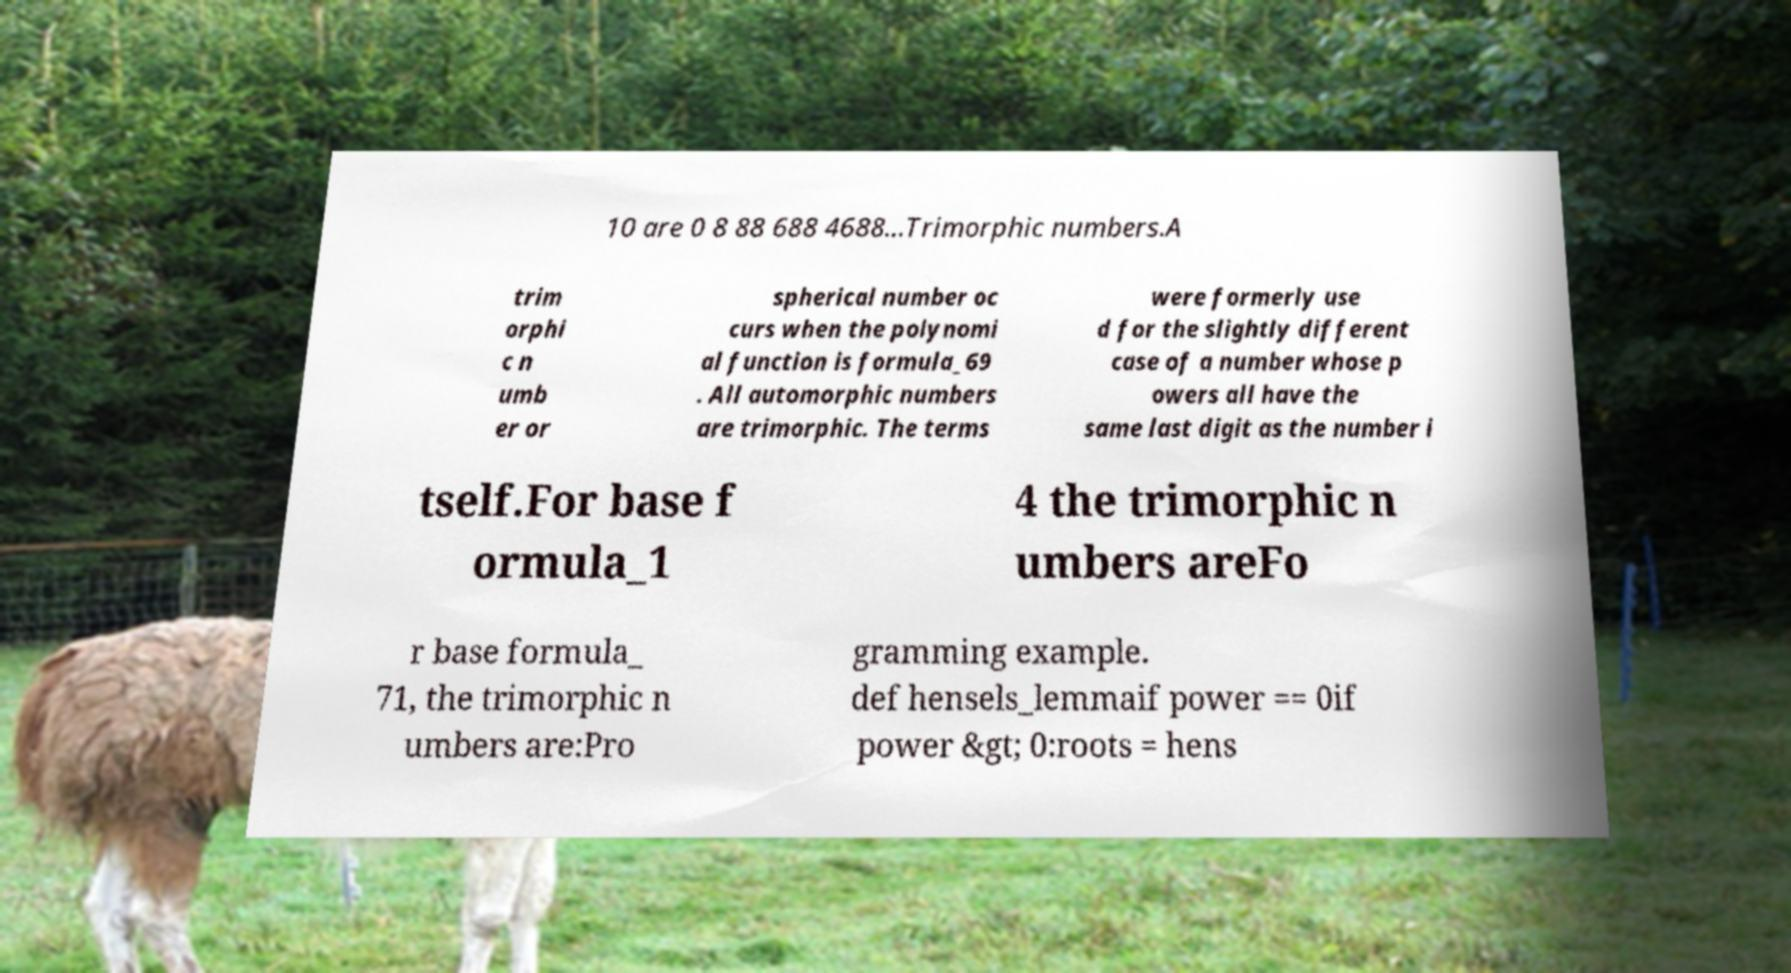What messages or text are displayed in this image? I need them in a readable, typed format. 10 are 0 8 88 688 4688...Trimorphic numbers.A trim orphi c n umb er or spherical number oc curs when the polynomi al function is formula_69 . All automorphic numbers are trimorphic. The terms were formerly use d for the slightly different case of a number whose p owers all have the same last digit as the number i tself.For base f ormula_1 4 the trimorphic n umbers areFo r base formula_ 71, the trimorphic n umbers are:Pro gramming example. def hensels_lemmaif power == 0if power &gt; 0:roots = hens 